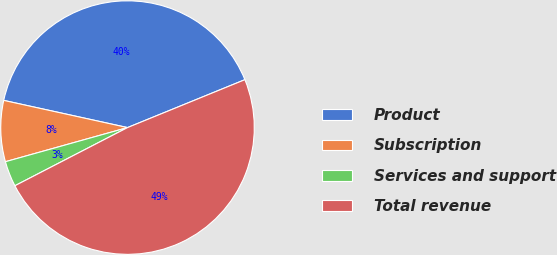<chart> <loc_0><loc_0><loc_500><loc_500><pie_chart><fcel>Product<fcel>Subscription<fcel>Services and support<fcel>Total revenue<nl><fcel>40.39%<fcel>7.78%<fcel>3.25%<fcel>48.58%<nl></chart> 